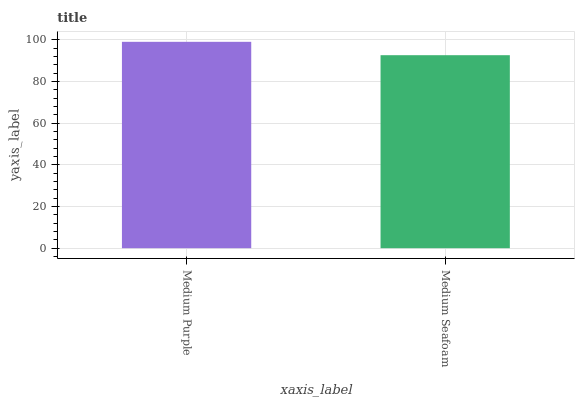Is Medium Seafoam the maximum?
Answer yes or no. No. Is Medium Purple greater than Medium Seafoam?
Answer yes or no. Yes. Is Medium Seafoam less than Medium Purple?
Answer yes or no. Yes. Is Medium Seafoam greater than Medium Purple?
Answer yes or no. No. Is Medium Purple less than Medium Seafoam?
Answer yes or no. No. Is Medium Purple the high median?
Answer yes or no. Yes. Is Medium Seafoam the low median?
Answer yes or no. Yes. Is Medium Seafoam the high median?
Answer yes or no. No. Is Medium Purple the low median?
Answer yes or no. No. 